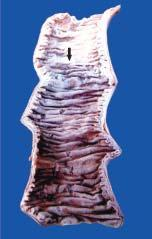s the infarcted area swollen, dark in colour and coated with fibrinous exudate?
Answer the question using a single word or phrase. Yes 